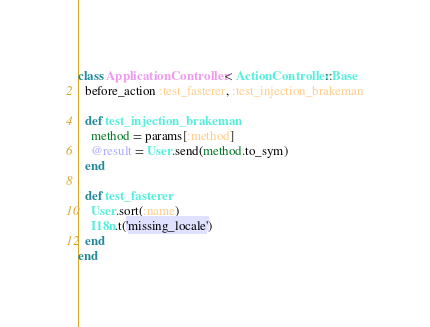<code> <loc_0><loc_0><loc_500><loc_500><_Ruby_>class ApplicationController < ActionController::Base
  before_action :test_fasterer, :test_injection_brakeman

  def test_injection_brakeman
    method = params[:method]
    @result = User.send(method.to_sym)
  end

  def test_fasterer
    User.sort(:name)
    I18n.t('missing_locale')
  end
end
</code> 